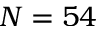Convert formula to latex. <formula><loc_0><loc_0><loc_500><loc_500>N = 5 4</formula> 